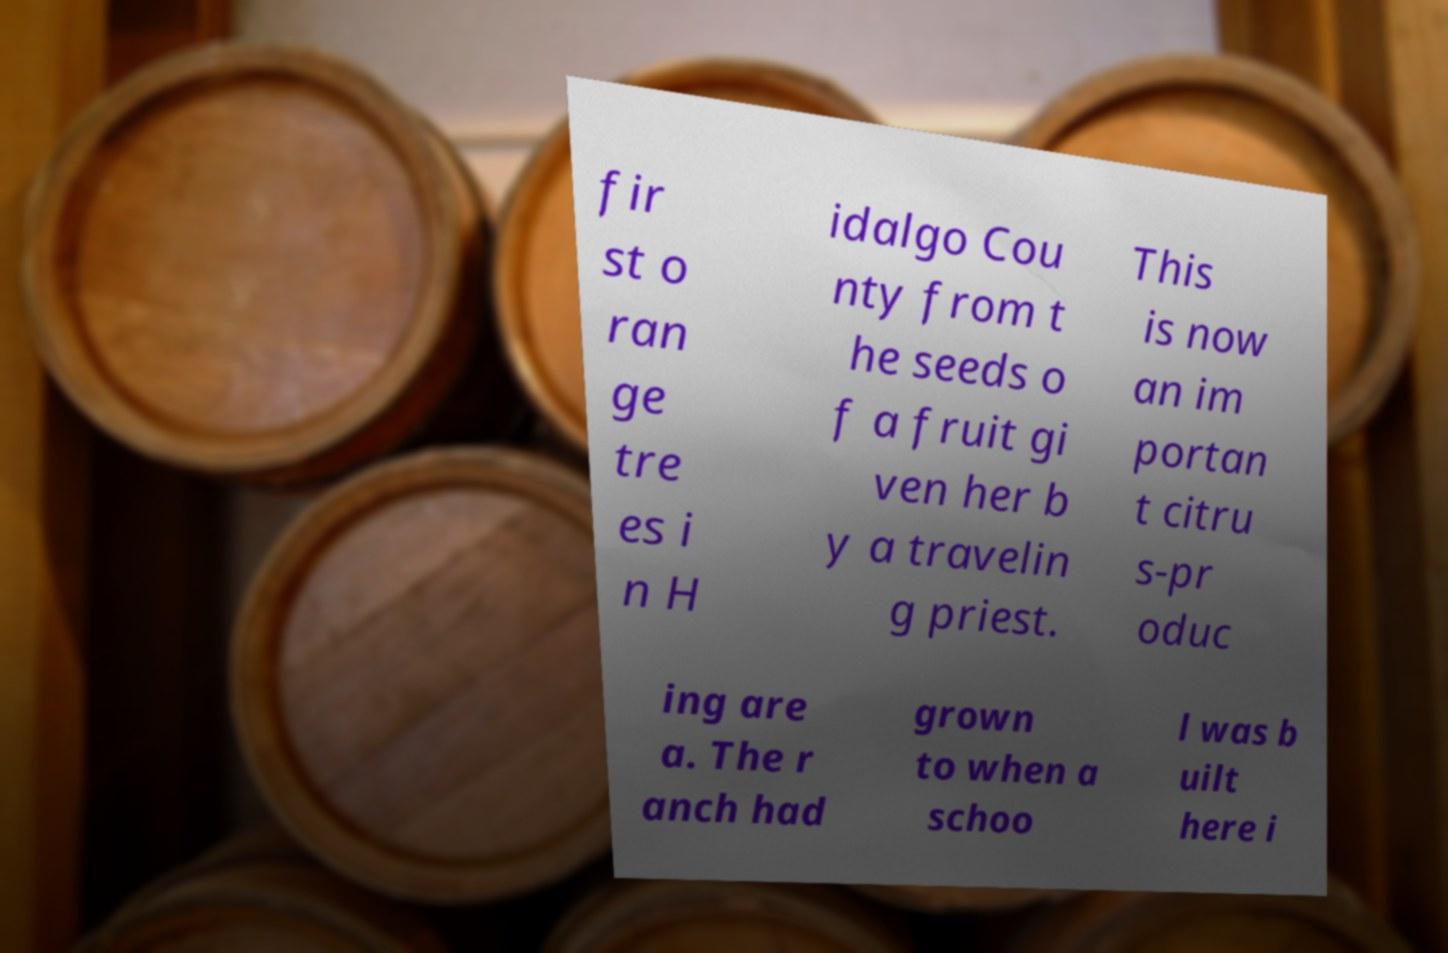Please read and relay the text visible in this image. What does it say? fir st o ran ge tre es i n H idalgo Cou nty from t he seeds o f a fruit gi ven her b y a travelin g priest. This is now an im portan t citru s-pr oduc ing are a. The r anch had grown to when a schoo l was b uilt here i 